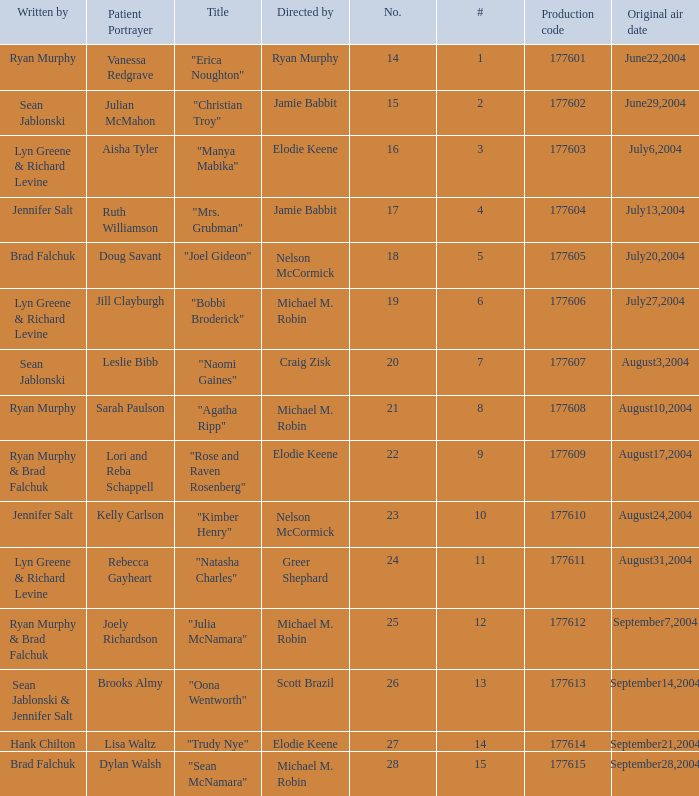What is the highest numbered episode with patient portrayer doug savant? 5.0. 